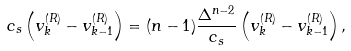Convert formula to latex. <formula><loc_0><loc_0><loc_500><loc_500>c _ { s } \left ( v ^ { ( R ) } _ { k } - v ^ { ( R ) } _ { k - 1 } \right ) = ( n - 1 ) \frac { \Delta ^ { n - 2 } } { c _ { s } } \left ( v ^ { ( R ) } _ { k } - v ^ { ( R ) } _ { k - 1 } \right ) ,</formula> 